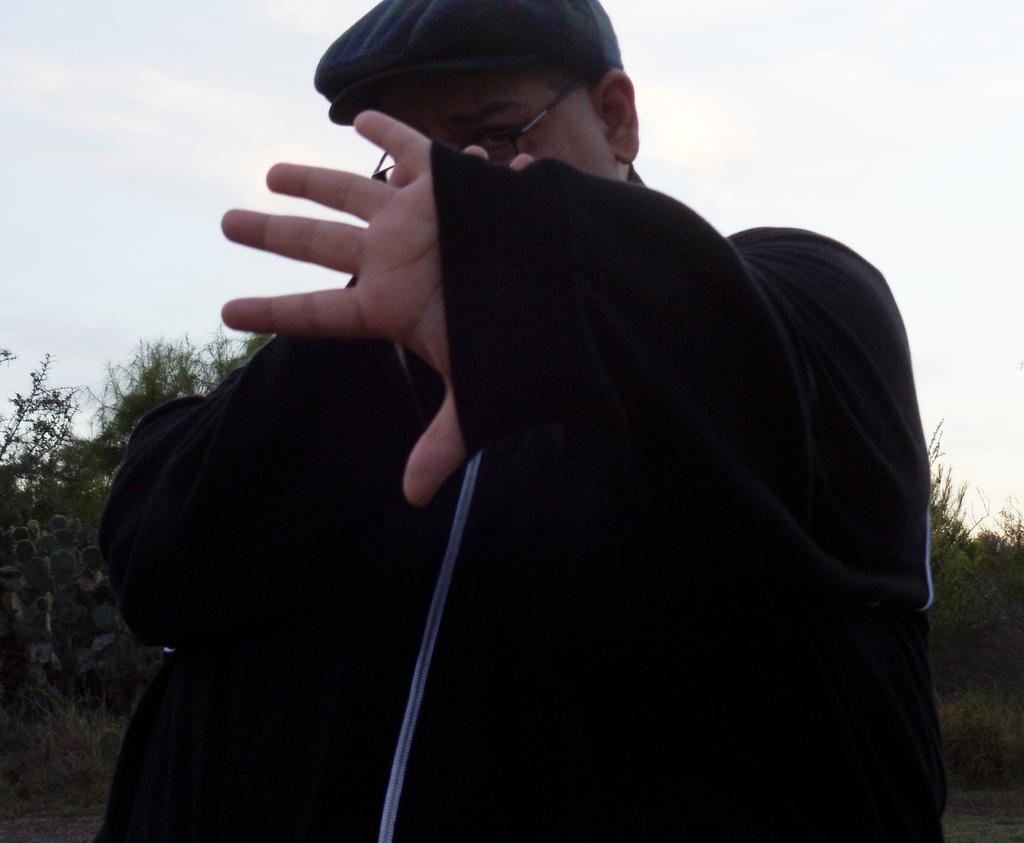What is the main subject of the image? There is a man standing in the image. What is the man wearing on his head? The man is wearing a cap on his head. What can be seen in the background of the image? There are trees visible in the background of the image. How would you describe the sky in the image? The sky appears to be cloudy in the image. What key is the man using to smash the trees in the image? There is no key or tree-smashing activity present in the image. 